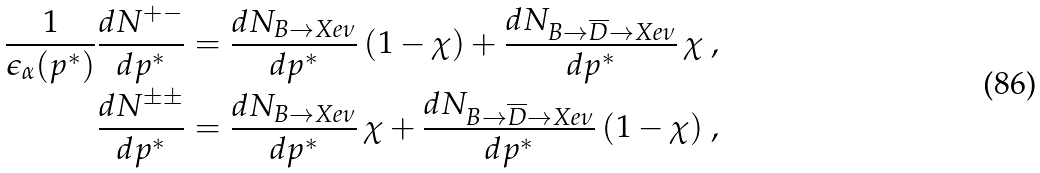<formula> <loc_0><loc_0><loc_500><loc_500>\frac { 1 } { \epsilon _ { \alpha } ( p ^ { * } ) } \frac { d N ^ { + - } } { d p ^ { * } } & = \frac { d N _ { B \to X e \nu } } { d p ^ { * } } \, ( 1 - \chi ) + \frac { d N _ { B \to \overline { D } \to X e \nu } } { d p ^ { * } } \, \chi \ , \\ \frac { d N ^ { \pm \pm } } { d p ^ { * } } & = \frac { d N _ { B \to X e \nu } } { d p ^ { * } } \, \chi + \frac { d N _ { B \to \overline { D } \to X e \nu } } { d p ^ { * } } \, ( 1 - \chi ) \ ,</formula> 